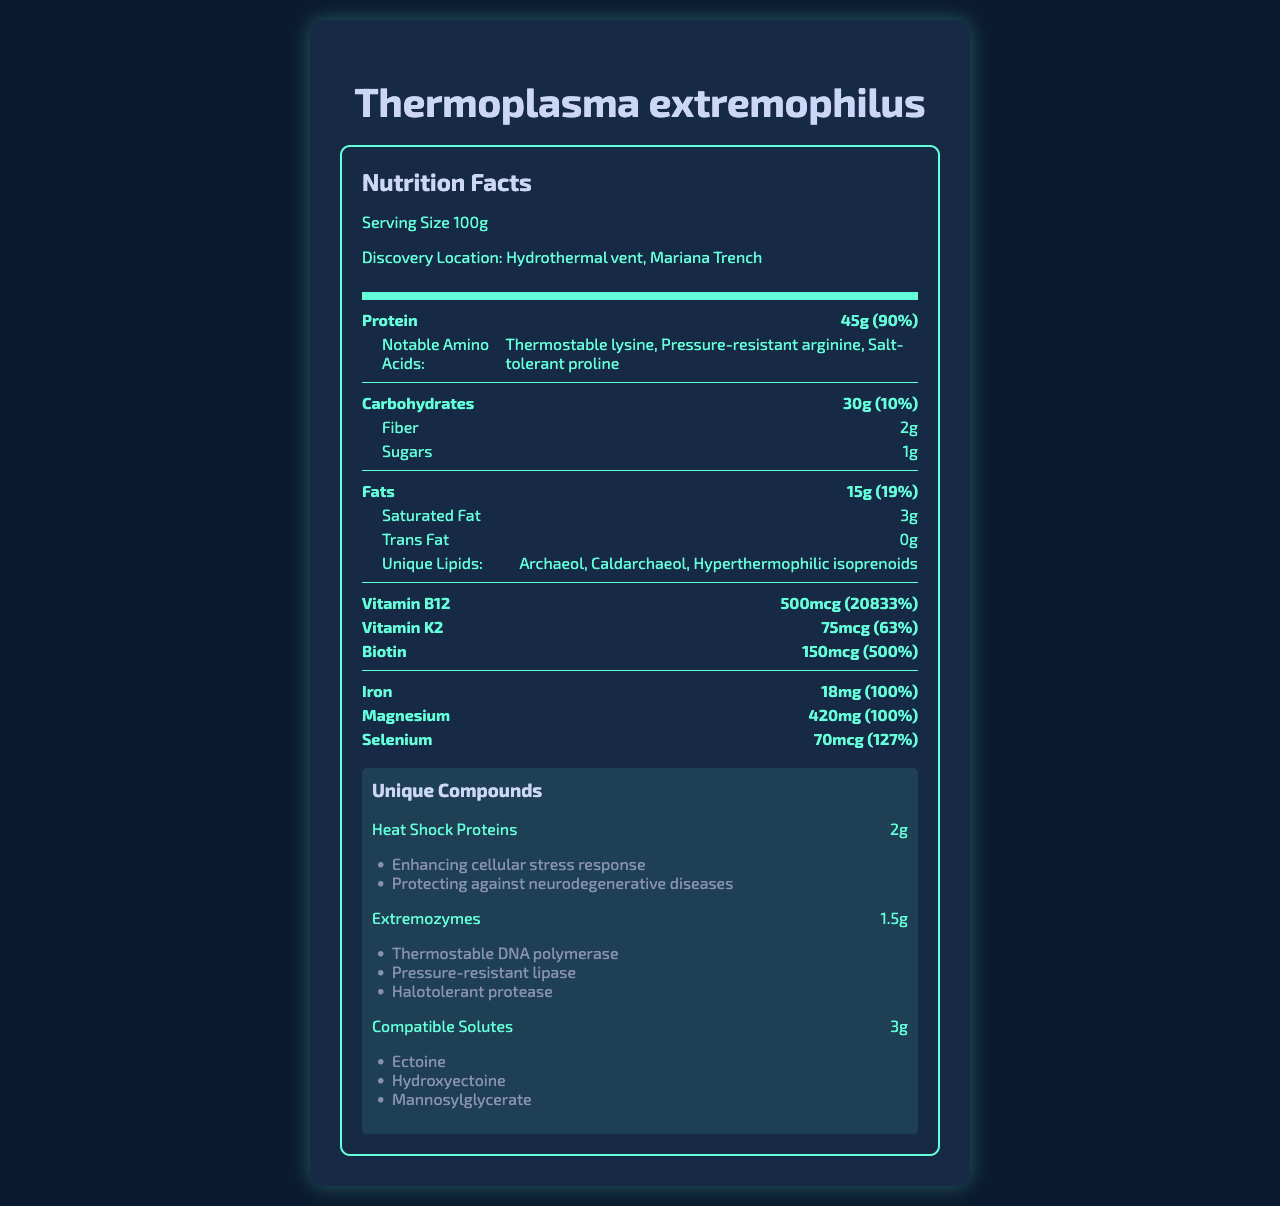what is the serving size of Thermoplasma extremophilus? The serving size is stated near the top of the document: "Serving Size 100g".
Answer: 100g where was Thermoplasma extremophilus discovered? The discovery location is provided under the serving size in the document.
Answer: Hydrothermal vent, Mariana Trench how much protein does Thermoplasma extremophilus contain per serving? The "Protein" section in the macronutrients part lists 45g.
Answer: 45g what are the notable amino acids found in Thermoplasma extremophilus? These are listed under the "Protein" section in the macronutrients part.
Answer: Thermostable lysine, Pressure-resistant arginine, Salt-tolerant proline what potential applications do heat shock proteins have? These potential applications are listed under the "Heat Shock Proteins" section in the unique compounds part.
Answer: Enhancing cellular stress response, Protecting against neurodegenerative diseases how much saturated fat is in a 100g serving? The "Saturated Fat" section under the "Fats" category lists 3g.
Answer: 3g what is the percent daily value of Vitamin B12? This percentage is listed next to the amount of Vitamin B12 in the vitamins subsection of micronutrients.
Answer: 20833% how much fiber is in Thermoplasma extremophilus per serving? The "Fiber" section under carbohydrates lists 2g.
Answer: 2g which of the following unique lipids are found in Thermoplasma extremophilus? A. Archaeol B. Myristoyl alcohol C. Cholesterol D. Phytosterol The unique lipids listed in the fats section are Archaeol, Caldarchaeol, and Hyperthermophilic isoprenoids. Myristoyl alcohol, Cholesterol, and Phytosterol are not listed.
Answer: A which applications are potential uses for extremozymes? A. Enhancing cellular stress response B. PCR optimization C. Space exploration D. Protein stabilization The extremozymes section lists PCR optimization as a potential application. The other options are not listed under extremozymes.
Answer: B does Thermoplasma extremophilus contain any trans fat? The trans fat content is listed as 0g in the macronutrients section under fats.
Answer: No can the amount of carbohydrates in Thermoplasma extremophilus be determined from the document? The document lists "30g" under "Carbohydrates" in the macronutrients part.
Answer: Yes summarize the main ideas of the nutrition facts document for Thermoplasma extremophilus The summary encapsulates key elements like macronutrients, micronutrients, unique compounds, biotechnological potential, and research implications, providing a holistic overview of the document.
Answer: The document provides detailed nutritional information for Thermoplasma extremophilus, including macronutrients like protein, carbohydrates, and fats, with notable amino acids and unique lipids. It also details micronutrients such as vitamins and minerals and specifies unique compounds like heat shock proteins and extremozymes with their potential applications. Additionally, it outlines the biotechnological potential and research implications in various fields. who is conducting the research on Thermoplasma extremophilus? The document does not provide any information regarding who is conducting the research.
Answer: Cannot be determined 